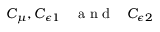Convert formula to latex. <formula><loc_0><loc_0><loc_500><loc_500>C _ { \mu } , C _ { \epsilon 1 } \, \ a n d \, \ C _ { \epsilon 2 }</formula> 